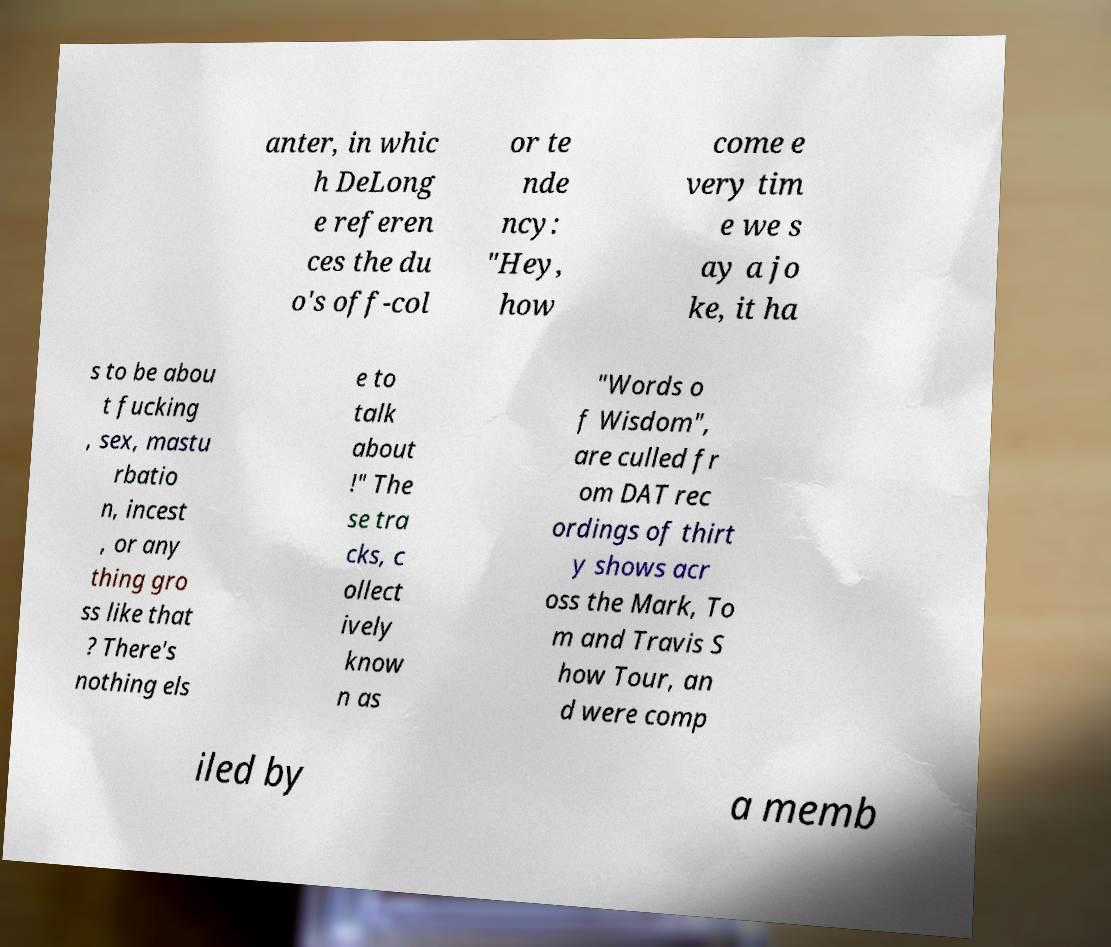There's text embedded in this image that I need extracted. Can you transcribe it verbatim? anter, in whic h DeLong e referen ces the du o's off-col or te nde ncy: "Hey, how come e very tim e we s ay a jo ke, it ha s to be abou t fucking , sex, mastu rbatio n, incest , or any thing gro ss like that ? There's nothing els e to talk about !" The se tra cks, c ollect ively know n as "Words o f Wisdom", are culled fr om DAT rec ordings of thirt y shows acr oss the Mark, To m and Travis S how Tour, an d were comp iled by a memb 